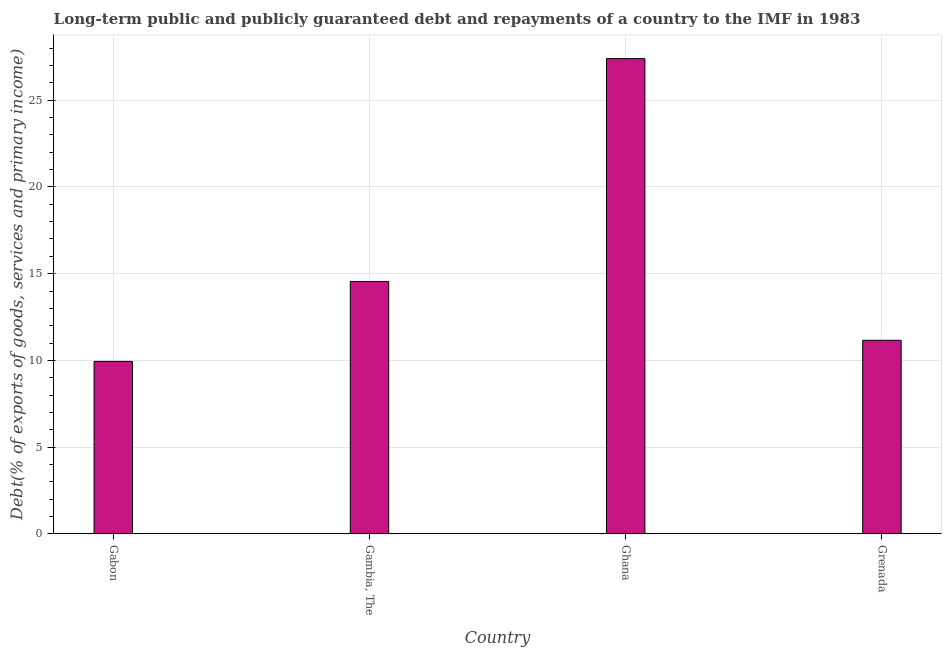Does the graph contain grids?
Offer a very short reply. Yes. What is the title of the graph?
Give a very brief answer. Long-term public and publicly guaranteed debt and repayments of a country to the IMF in 1983. What is the label or title of the Y-axis?
Provide a short and direct response. Debt(% of exports of goods, services and primary income). What is the debt service in Ghana?
Your answer should be compact. 27.4. Across all countries, what is the maximum debt service?
Your response must be concise. 27.4. Across all countries, what is the minimum debt service?
Offer a terse response. 9.94. In which country was the debt service minimum?
Make the answer very short. Gabon. What is the sum of the debt service?
Offer a terse response. 63.05. What is the difference between the debt service in Ghana and Grenada?
Your response must be concise. 16.24. What is the average debt service per country?
Give a very brief answer. 15.76. What is the median debt service?
Provide a short and direct response. 12.85. In how many countries, is the debt service greater than 1 %?
Your answer should be compact. 4. What is the ratio of the debt service in Gabon to that in Ghana?
Keep it short and to the point. 0.36. Is the difference between the debt service in Gabon and Ghana greater than the difference between any two countries?
Your answer should be compact. Yes. What is the difference between the highest and the second highest debt service?
Your response must be concise. 12.85. What is the difference between the highest and the lowest debt service?
Ensure brevity in your answer.  17.46. In how many countries, is the debt service greater than the average debt service taken over all countries?
Provide a short and direct response. 1. How many bars are there?
Provide a short and direct response. 4. Are all the bars in the graph horizontal?
Keep it short and to the point. No. How many countries are there in the graph?
Your answer should be compact. 4. What is the Debt(% of exports of goods, services and primary income) in Gabon?
Ensure brevity in your answer.  9.94. What is the Debt(% of exports of goods, services and primary income) of Gambia, The?
Provide a succinct answer. 14.55. What is the Debt(% of exports of goods, services and primary income) of Ghana?
Your response must be concise. 27.4. What is the Debt(% of exports of goods, services and primary income) in Grenada?
Your response must be concise. 11.16. What is the difference between the Debt(% of exports of goods, services and primary income) in Gabon and Gambia, The?
Make the answer very short. -4.61. What is the difference between the Debt(% of exports of goods, services and primary income) in Gabon and Ghana?
Your response must be concise. -17.46. What is the difference between the Debt(% of exports of goods, services and primary income) in Gabon and Grenada?
Provide a succinct answer. -1.22. What is the difference between the Debt(% of exports of goods, services and primary income) in Gambia, The and Ghana?
Your answer should be very brief. -12.85. What is the difference between the Debt(% of exports of goods, services and primary income) in Gambia, The and Grenada?
Offer a very short reply. 3.39. What is the difference between the Debt(% of exports of goods, services and primary income) in Ghana and Grenada?
Offer a very short reply. 16.24. What is the ratio of the Debt(% of exports of goods, services and primary income) in Gabon to that in Gambia, The?
Your answer should be compact. 0.68. What is the ratio of the Debt(% of exports of goods, services and primary income) in Gabon to that in Ghana?
Your answer should be very brief. 0.36. What is the ratio of the Debt(% of exports of goods, services and primary income) in Gabon to that in Grenada?
Provide a short and direct response. 0.89. What is the ratio of the Debt(% of exports of goods, services and primary income) in Gambia, The to that in Ghana?
Your answer should be compact. 0.53. What is the ratio of the Debt(% of exports of goods, services and primary income) in Gambia, The to that in Grenada?
Ensure brevity in your answer.  1.3. What is the ratio of the Debt(% of exports of goods, services and primary income) in Ghana to that in Grenada?
Offer a terse response. 2.46. 